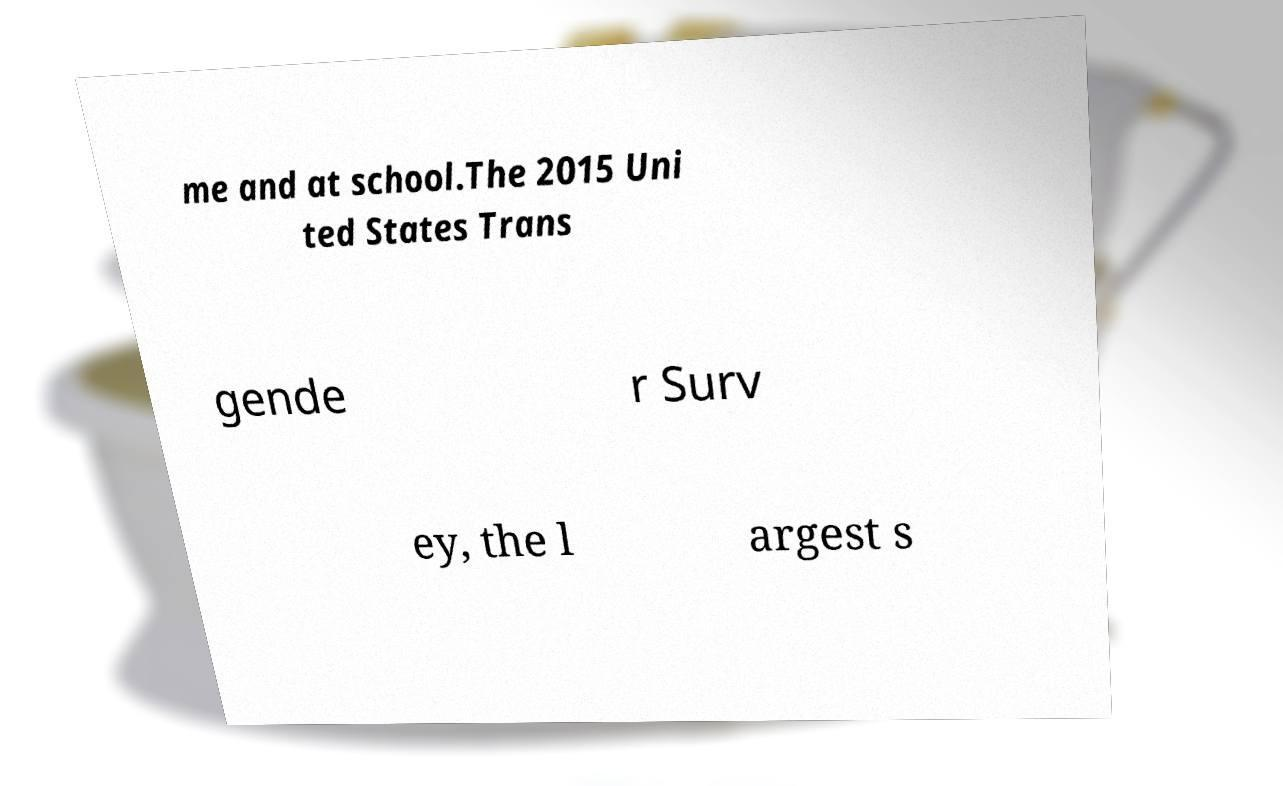What messages or text are displayed in this image? I need them in a readable, typed format. me and at school.The 2015 Uni ted States Trans gende r Surv ey, the l argest s 